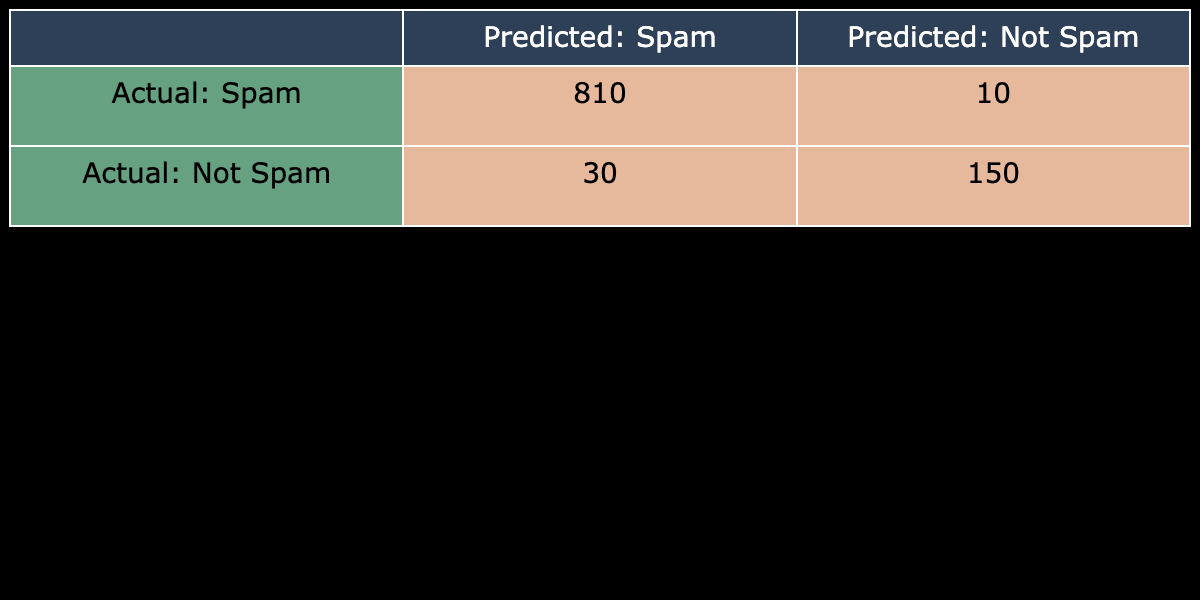What is the total number of actual spam emails? The total number of actual spam emails can be found by summing the counts in the "Actual: Spam" row, which consists of 150 (predicted as Spam) and 30 (predicted as Not Spam). Therefore, total spam emails = 150 + 30 = 180.
Answer: 180 What is the total number of actual non-spam emails? The total number of actual non-spam emails can be calculated by summing the counts in the "Actual: Not Spam" row, which consists of 10 (predicted as Spam) and 810 (predicted as Not Spam). Therefore, total non-spam emails = 10 + 810 = 820.
Answer: 820 Is the number of correctly identified spam emails greater than the number of incorrectly identified non-spam emails? The number of correctly identified spam emails is 150, while the number of incorrectly identified non-spam emails is 10. Since 150 is greater than 10, the statement is true.
Answer: Yes How many total predictions were made for spam? To find the total predictions made for spam, we add the counts for both predicted outcomes under "Predicted: Spam," which is 150 (Actual: Spam) and 10 (Actual: Not Spam). Thus, the total predictions for spam = 150 + 10 = 160.
Answer: 160 What is the proportion of actual spam emails that were correctly classified? The proportion of actual spam emails correctly classified is calculated by dividing the number of correctly identified spam emails (150) by the total number of actual spam emails (180) and then multiplying by 100 for percentage. So, proportion = (150 / 180) * 100 ≈ 83.33%.
Answer: 83.33% What is the count of emails that were predicted to be spam? We find the count of emails predicted to be spam by summing the counts in the "Predicted: Spam" column, which consists of 150 (actual spam) and 10 (actual non-spam). Therefore, the count of emails predicted to be spam = 150 + 10 = 160.
Answer: 160 What is the count of non-spam emails classified as spam? The count of non-spam emails that were classified as spam is given in the table as 10 (from the "Not Spam" row under "Predicted: Spam").
Answer: 10 What is the total number of emails analyzed? To find the total number of emails analyzed, we add all the counts from the table: 150 (Spam, Spam) + 30 (Spam, Not Spam) + 10 (Not Spam, Spam) + 810 (Not Spam, Not Spam). Therefore, total emails = 150 + 30 + 10 + 810 = 1000.
Answer: 1000 Were there more emails correctly classified as not spam than incorrectly classified as spam? The number of emails correctly classified as not spam is 810, while the number of emails incorrectly classified as spam is 30. Since 810 is greater than 30, the statement is true.
Answer: Yes What is the total count of emails that were both actually spam and predicted as not spam? The total count of emails that were actually spam and predicted as not spam is given directly in the table as 30 (Spam, Not Spam).
Answer: 30 